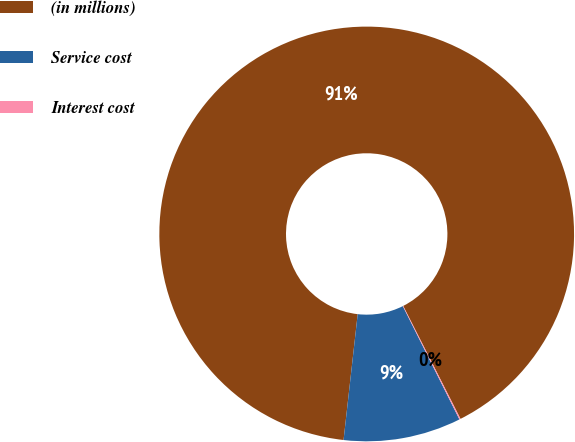Convert chart. <chart><loc_0><loc_0><loc_500><loc_500><pie_chart><fcel>(in millions)<fcel>Service cost<fcel>Interest cost<nl><fcel>90.75%<fcel>9.16%<fcel>0.09%<nl></chart> 